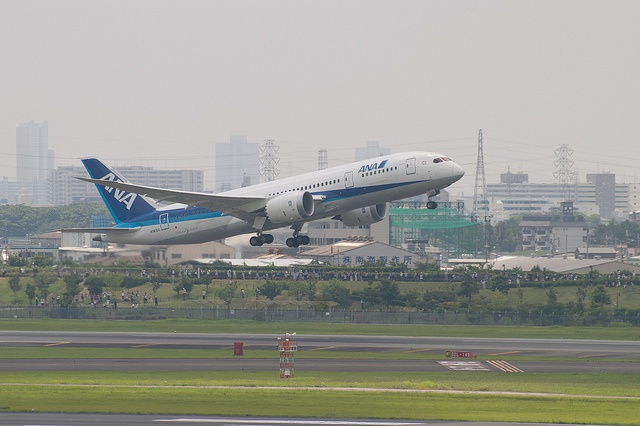Describe the objects in this image and their specific colors. I can see airplane in lightgray, gray, darkgray, and blue tones, people in lightgray, gray, purple, and darkgray tones, people in lightgray, gray, and darkblue tones, people in lightgray, gray, and darkblue tones, and people in lightgray, gray, and darkgray tones in this image. 